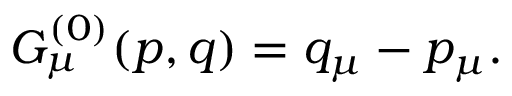<formula> <loc_0><loc_0><loc_500><loc_500>G _ { \mu } ^ { ( 0 ) } ( p , q ) = q _ { \mu } - p _ { \mu } .</formula> 